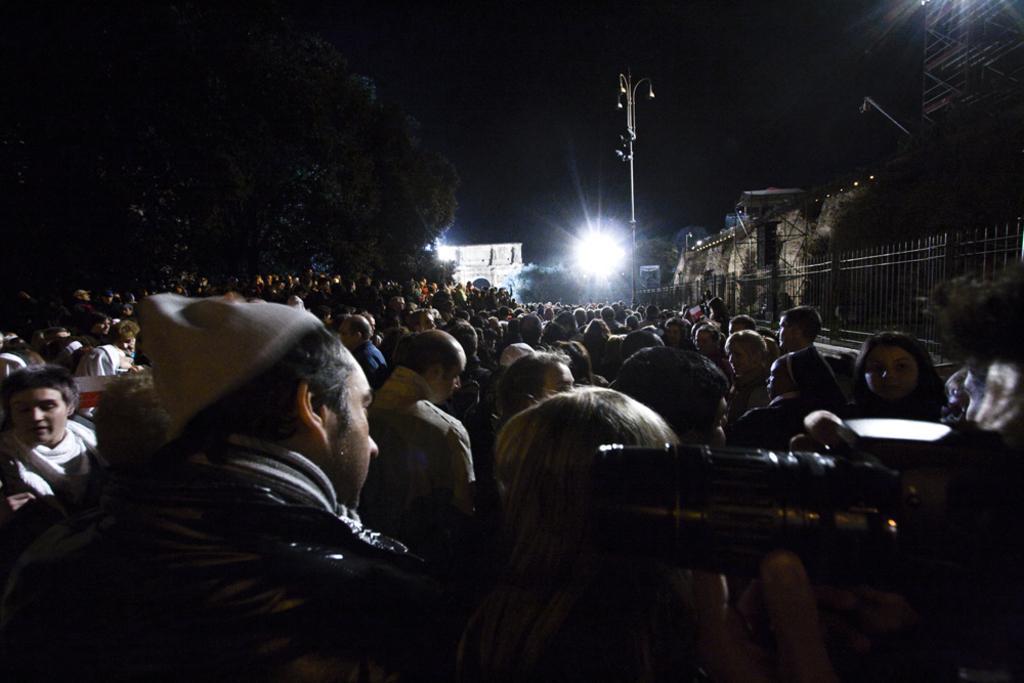Can you describe this image briefly? In this image we can see a crowd. On the right side we can see a person holding a camera. On the backside we can see some trees, buildings, fence and a street pole. 